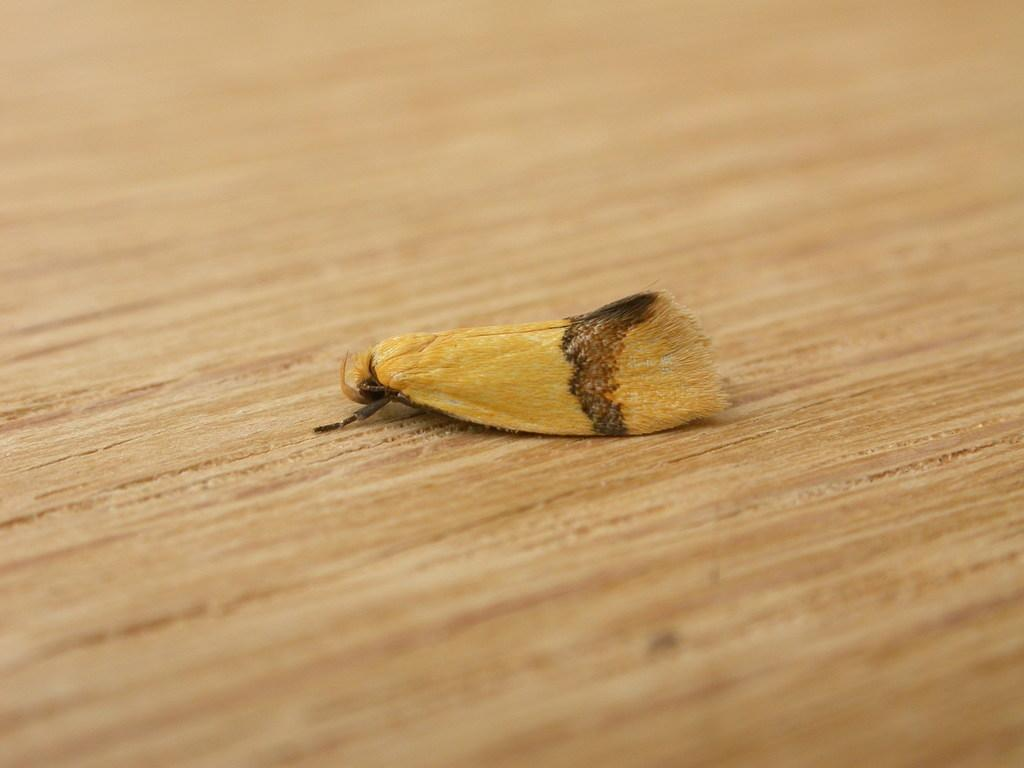What type of creature can be seen in the image? There is an insect in the image. Where is the insect located? The insect is present on a wooden surface. What type of judge is present in the image? There is no judge present in the image; it only features an insect on a wooden surface. 